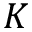<formula> <loc_0><loc_0><loc_500><loc_500>K</formula> 